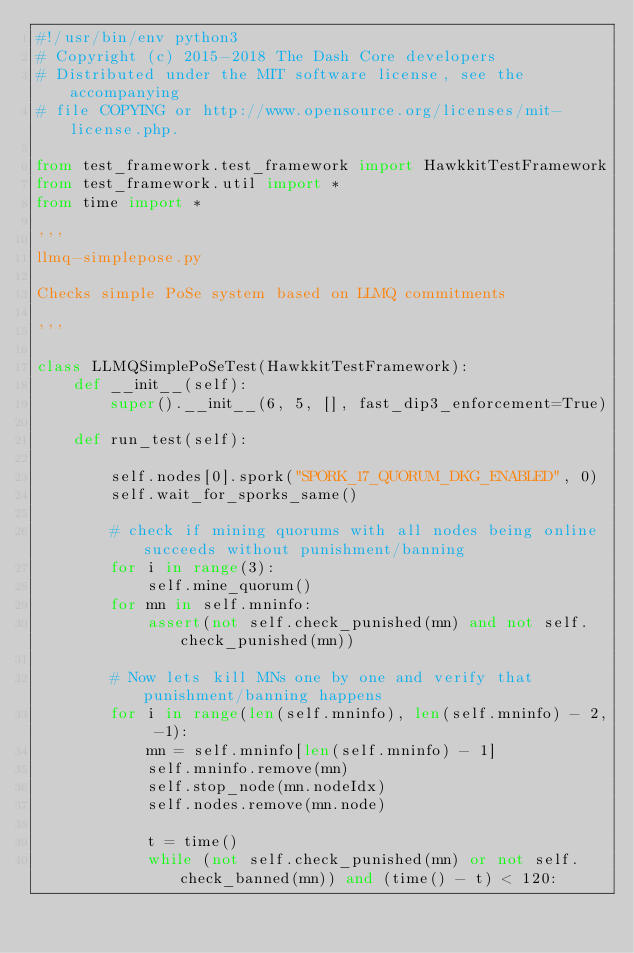<code> <loc_0><loc_0><loc_500><loc_500><_Python_>#!/usr/bin/env python3
# Copyright (c) 2015-2018 The Dash Core developers
# Distributed under the MIT software license, see the accompanying
# file COPYING or http://www.opensource.org/licenses/mit-license.php.

from test_framework.test_framework import HawkkitTestFramework
from test_framework.util import *
from time import *

'''
llmq-simplepose.py

Checks simple PoSe system based on LLMQ commitments

'''

class LLMQSimplePoSeTest(HawkkitTestFramework):
    def __init__(self):
        super().__init__(6, 5, [], fast_dip3_enforcement=True)

    def run_test(self):

        self.nodes[0].spork("SPORK_17_QUORUM_DKG_ENABLED", 0)
        self.wait_for_sporks_same()

        # check if mining quorums with all nodes being online succeeds without punishment/banning
        for i in range(3):
            self.mine_quorum()
        for mn in self.mninfo:
            assert(not self.check_punished(mn) and not self.check_punished(mn))

        # Now lets kill MNs one by one and verify that punishment/banning happens
        for i in range(len(self.mninfo), len(self.mninfo) - 2, -1):
            mn = self.mninfo[len(self.mninfo) - 1]
            self.mninfo.remove(mn)
            self.stop_node(mn.nodeIdx)
            self.nodes.remove(mn.node)

            t = time()
            while (not self.check_punished(mn) or not self.check_banned(mn)) and (time() - t) < 120:</code> 